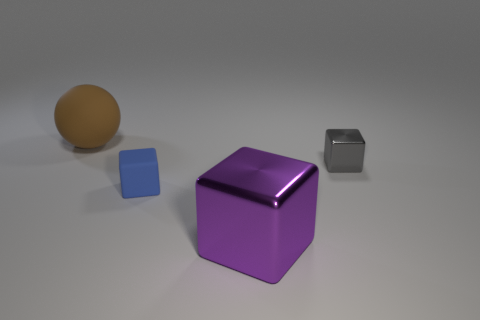What is the shape of the object that is both to the right of the tiny matte cube and on the left side of the tiny metal cube?
Ensure brevity in your answer.  Cube. How many other objects are there of the same shape as the big rubber thing?
Your answer should be very brief. 0. Are there the same number of small gray metallic blocks that are behind the big brown thing and tiny brown metallic spheres?
Offer a terse response. Yes. What material is the tiny cube behind the matte thing on the right side of the ball?
Keep it short and to the point. Metal. The small shiny object is what shape?
Provide a short and direct response. Cube. Is the number of gray metallic things in front of the tiny gray thing the same as the number of large purple cubes behind the big brown object?
Provide a succinct answer. Yes. There is a rubber thing in front of the brown sphere; is its color the same as the tiny object that is behind the tiny blue thing?
Provide a short and direct response. No. Are there more matte spheres to the right of the big purple metal block than small yellow spheres?
Offer a terse response. No. What is the shape of the gray object that is made of the same material as the large cube?
Provide a short and direct response. Cube. Do the object that is left of the blue matte object and the small blue block have the same size?
Offer a terse response. No. 